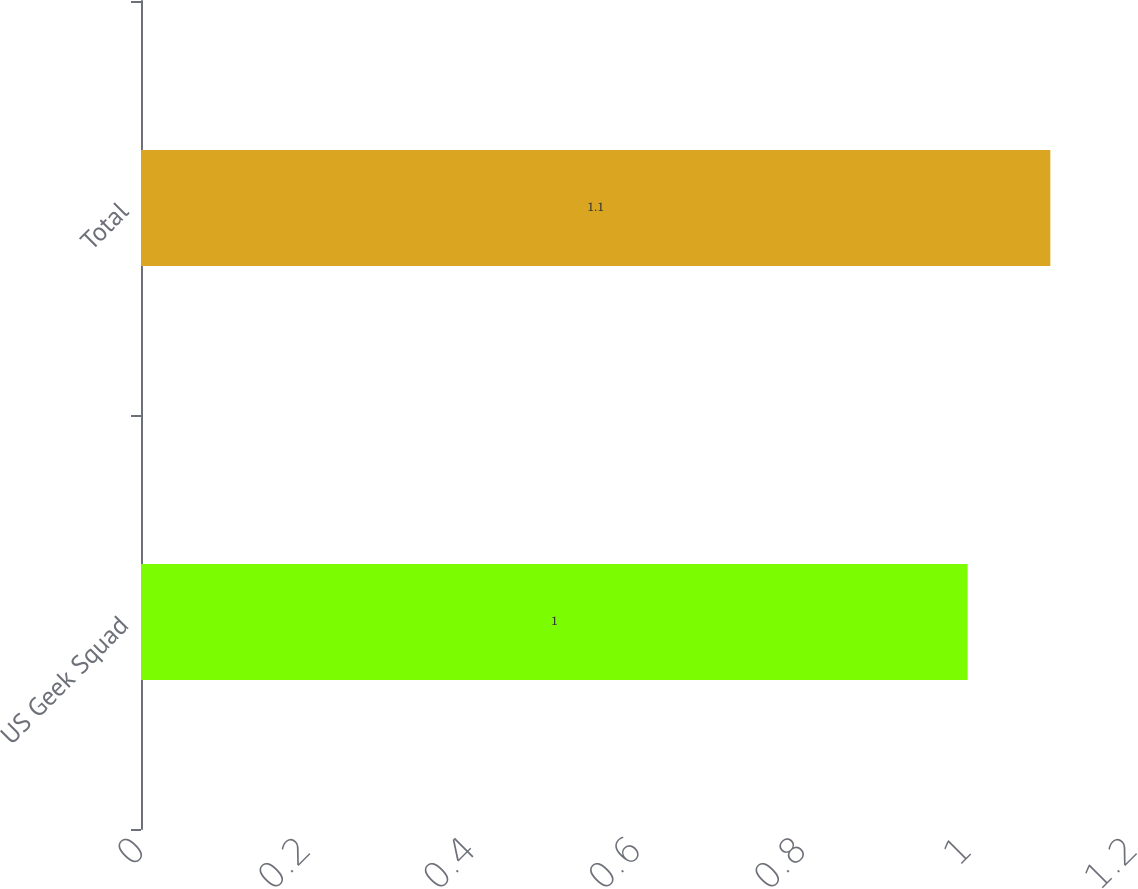Convert chart. <chart><loc_0><loc_0><loc_500><loc_500><bar_chart><fcel>US Geek Squad<fcel>Total<nl><fcel>1<fcel>1.1<nl></chart> 